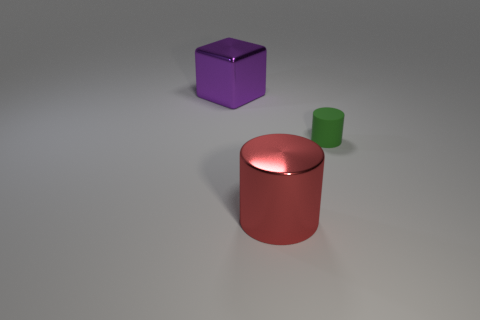Is there anything else that has the same shape as the purple object?
Offer a very short reply. No. Is there any other thing that is the same size as the green thing?
Give a very brief answer. No. What is the material of the green cylinder that is right of the large thing on the left side of the big thing in front of the purple cube?
Give a very brief answer. Rubber. Is there any other thing that is made of the same material as the green cylinder?
Offer a very short reply. No. What number of green things are cylinders or large cylinders?
Your answer should be very brief. 1. What number of other objects are there of the same shape as the matte object?
Provide a succinct answer. 1. Is the material of the tiny cylinder the same as the large cylinder?
Provide a short and direct response. No. What is the material of the object that is both to the right of the large shiny block and to the left of the green cylinder?
Make the answer very short. Metal. There is a large metallic object that is behind the big metallic cylinder; what color is it?
Give a very brief answer. Purple. Is the number of tiny things that are in front of the green rubber object greater than the number of green rubber things?
Offer a terse response. No. 